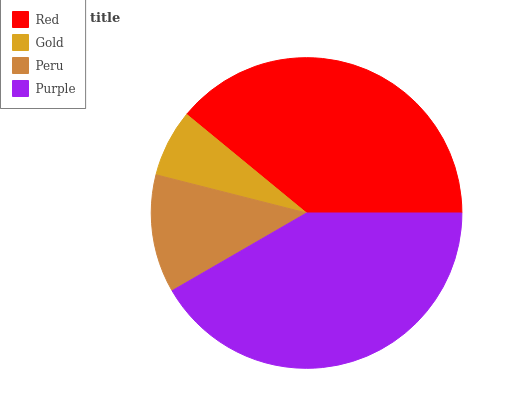Is Gold the minimum?
Answer yes or no. Yes. Is Purple the maximum?
Answer yes or no. Yes. Is Peru the minimum?
Answer yes or no. No. Is Peru the maximum?
Answer yes or no. No. Is Peru greater than Gold?
Answer yes or no. Yes. Is Gold less than Peru?
Answer yes or no. Yes. Is Gold greater than Peru?
Answer yes or no. No. Is Peru less than Gold?
Answer yes or no. No. Is Red the high median?
Answer yes or no. Yes. Is Peru the low median?
Answer yes or no. Yes. Is Peru the high median?
Answer yes or no. No. Is Red the low median?
Answer yes or no. No. 